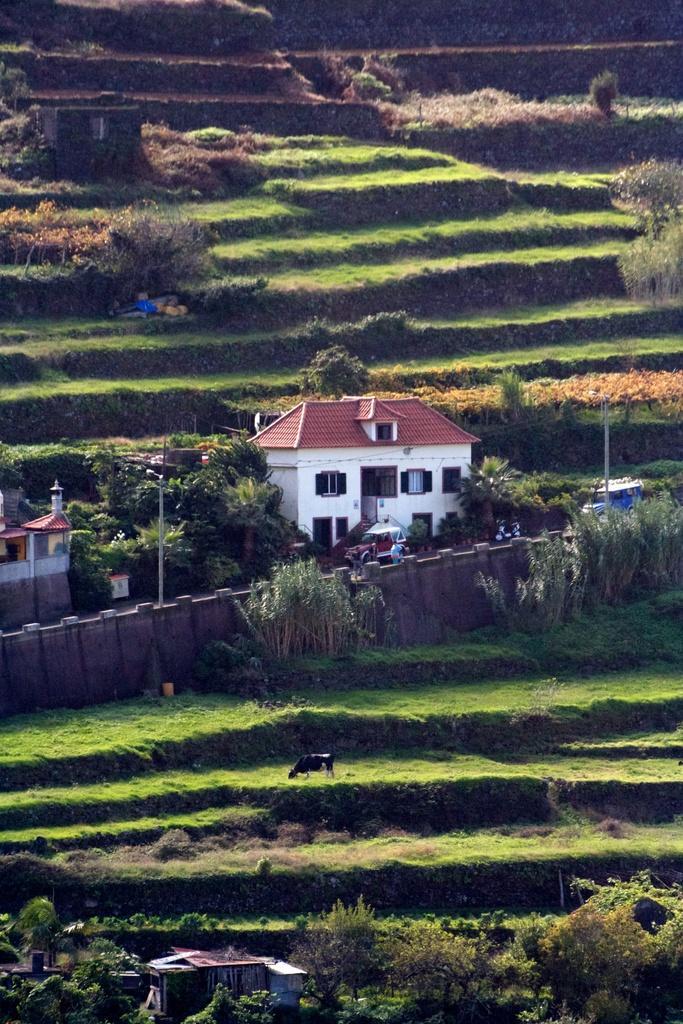Describe this image in one or two sentences. In this image, we can see houses, poles, a fence and there is an animal and there are trees and fields. 